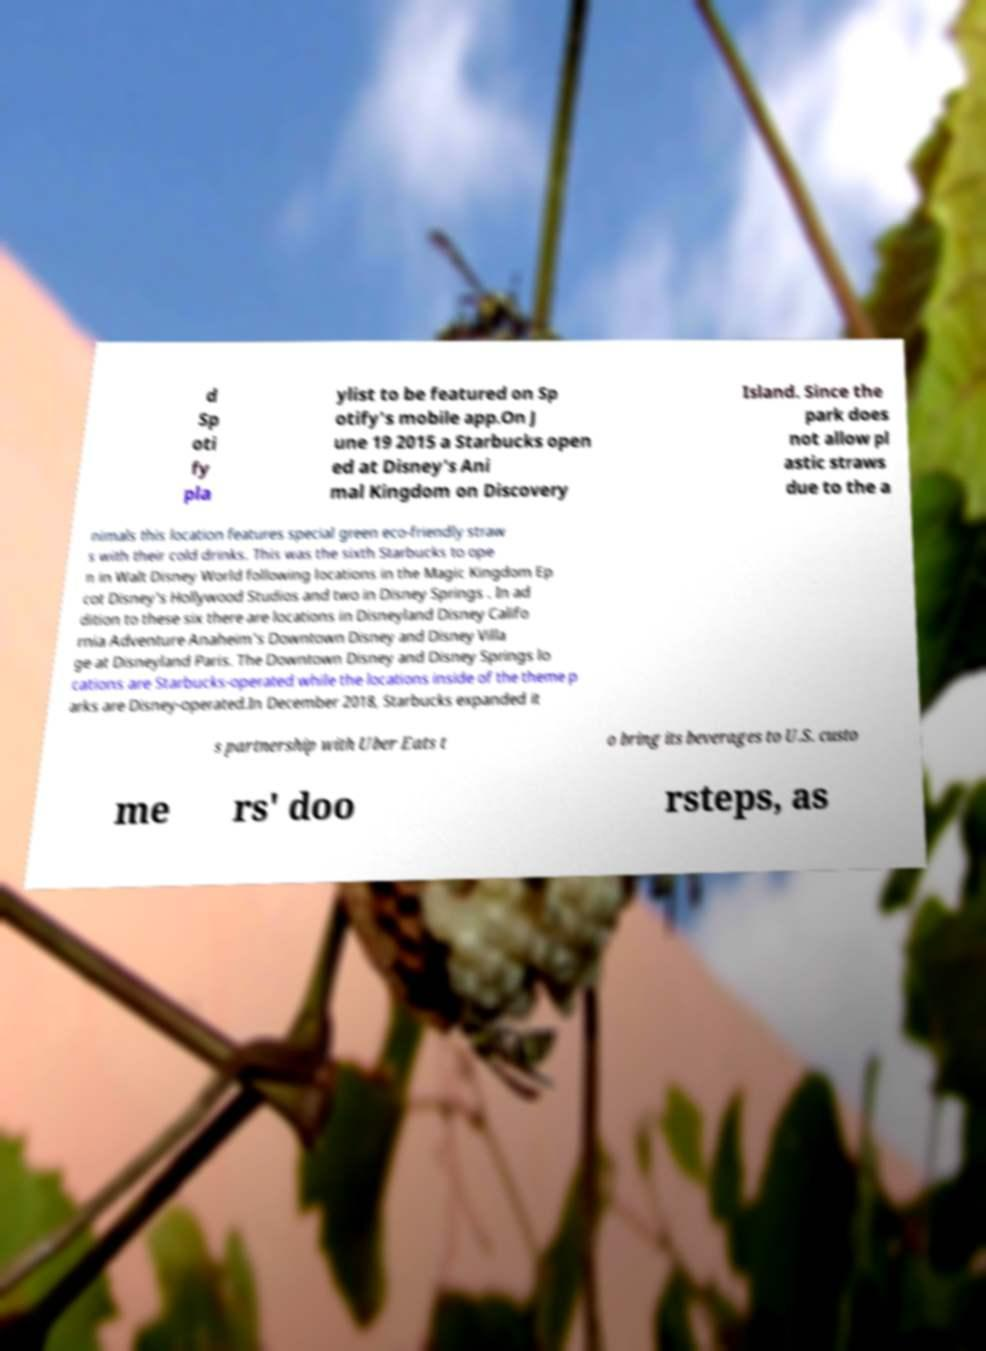I need the written content from this picture converted into text. Can you do that? d Sp oti fy pla ylist to be featured on Sp otify's mobile app.On J une 19 2015 a Starbucks open ed at Disney's Ani mal Kingdom on Discovery Island. Since the park does not allow pl astic straws due to the a nimals this location features special green eco-friendly straw s with their cold drinks. This was the sixth Starbucks to ope n in Walt Disney World following locations in the Magic Kingdom Ep cot Disney's Hollywood Studios and two in Disney Springs . In ad dition to these six there are locations in Disneyland Disney Califo rnia Adventure Anaheim's Downtown Disney and Disney Villa ge at Disneyland Paris. The Downtown Disney and Disney Springs lo cations are Starbucks-operated while the locations inside of the theme p arks are Disney-operated.In December 2018, Starbucks expanded it s partnership with Uber Eats t o bring its beverages to U.S. custo me rs' doo rsteps, as 